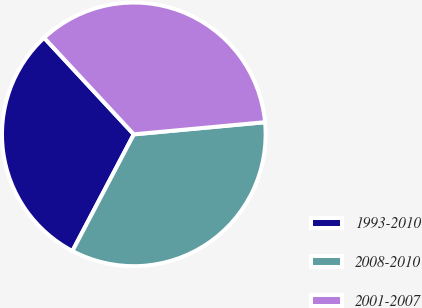Convert chart to OTSL. <chart><loc_0><loc_0><loc_500><loc_500><pie_chart><fcel>1993-2010<fcel>2008-2010<fcel>2001-2007<nl><fcel>30.38%<fcel>34.18%<fcel>35.44%<nl></chart> 